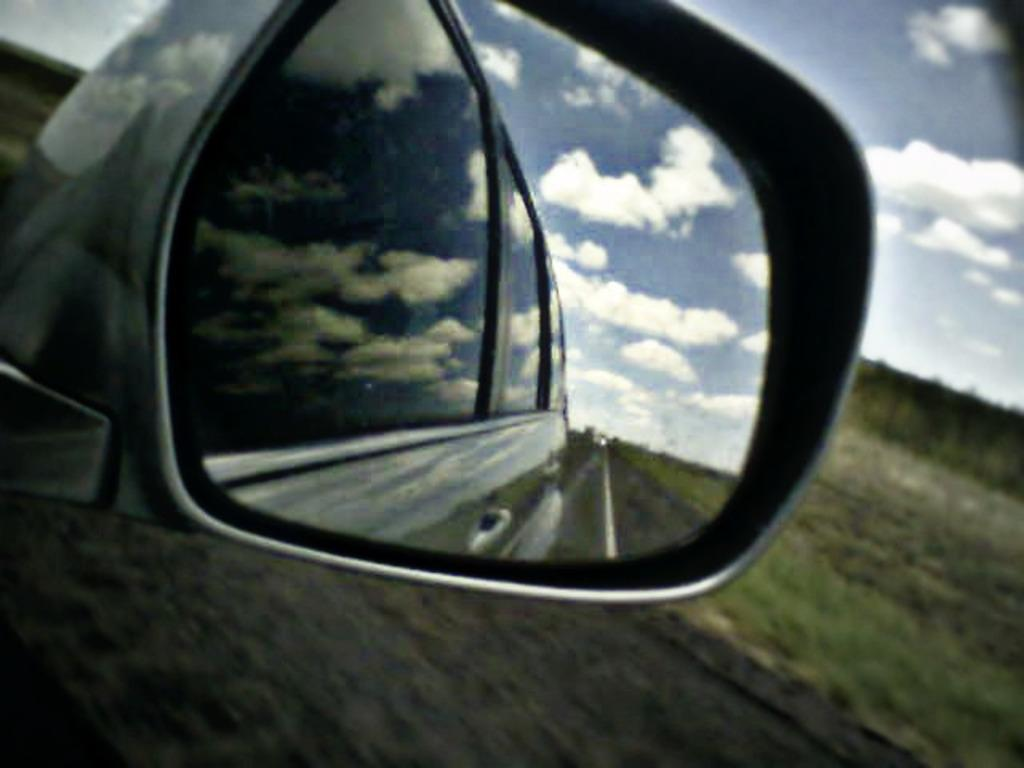What object is the main focus of the image? There is a car mirror in the image. What can be seen in the car mirror? The road and the sky are visible in the car mirror. What type of landscape is on the right side of the image? There is a grassland on the right side of the image. What is visible above the grassland? The sky is visible above the grassland. What time of day is it in the image, based on the presence of a fork? There is no fork present in the image, so it is not possible to determine the time of day based on that object. 